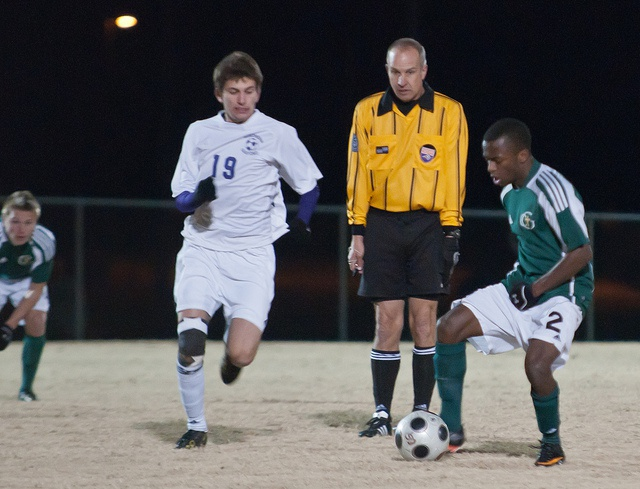Describe the objects in this image and their specific colors. I can see people in black, orange, and gray tones, people in black, lavender, and darkgray tones, people in black, teal, lavender, and gray tones, people in black, gray, darkgray, and blue tones, and sports ball in black, darkgray, lightgray, and gray tones in this image. 